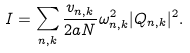Convert formula to latex. <formula><loc_0><loc_0><loc_500><loc_500>I = \sum _ { n , k } \frac { v _ { n , k } } { 2 a N } \omega _ { n , k } ^ { 2 } | Q _ { n , k } | ^ { 2 } .</formula> 